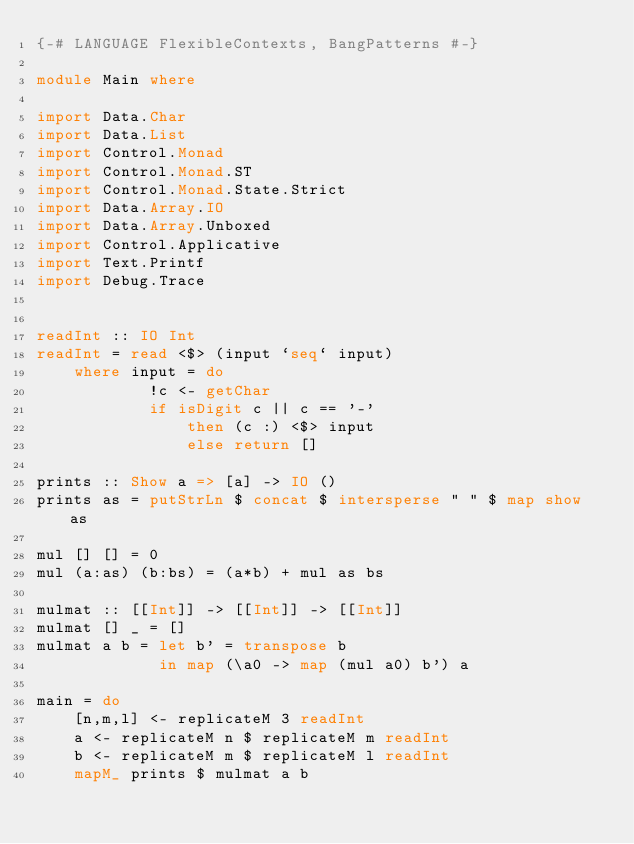Convert code to text. <code><loc_0><loc_0><loc_500><loc_500><_Haskell_>{-# LANGUAGE FlexibleContexts, BangPatterns #-}

module Main where

import Data.Char
import Data.List
import Control.Monad
import Control.Monad.ST
import Control.Monad.State.Strict
import Data.Array.IO
import Data.Array.Unboxed
import Control.Applicative
import Text.Printf
import Debug.Trace


readInt :: IO Int
readInt = read <$> (input `seq` input)
    where input = do
            !c <- getChar
            if isDigit c || c == '-'
                then (c :) <$> input
                else return []

prints :: Show a => [a] -> IO ()
prints as = putStrLn $ concat $ intersperse " " $ map show as

mul [] [] = 0
mul (a:as) (b:bs) = (a*b) + mul as bs

mulmat :: [[Int]] -> [[Int]] -> [[Int]]
mulmat [] _ = []
mulmat a b = let b' = transpose b
             in map (\a0 -> map (mul a0) b') a

main = do
    [n,m,l] <- replicateM 3 readInt
    a <- replicateM n $ replicateM m readInt
    b <- replicateM m $ replicateM l readInt
    mapM_ prints $ mulmat a b
</code> 